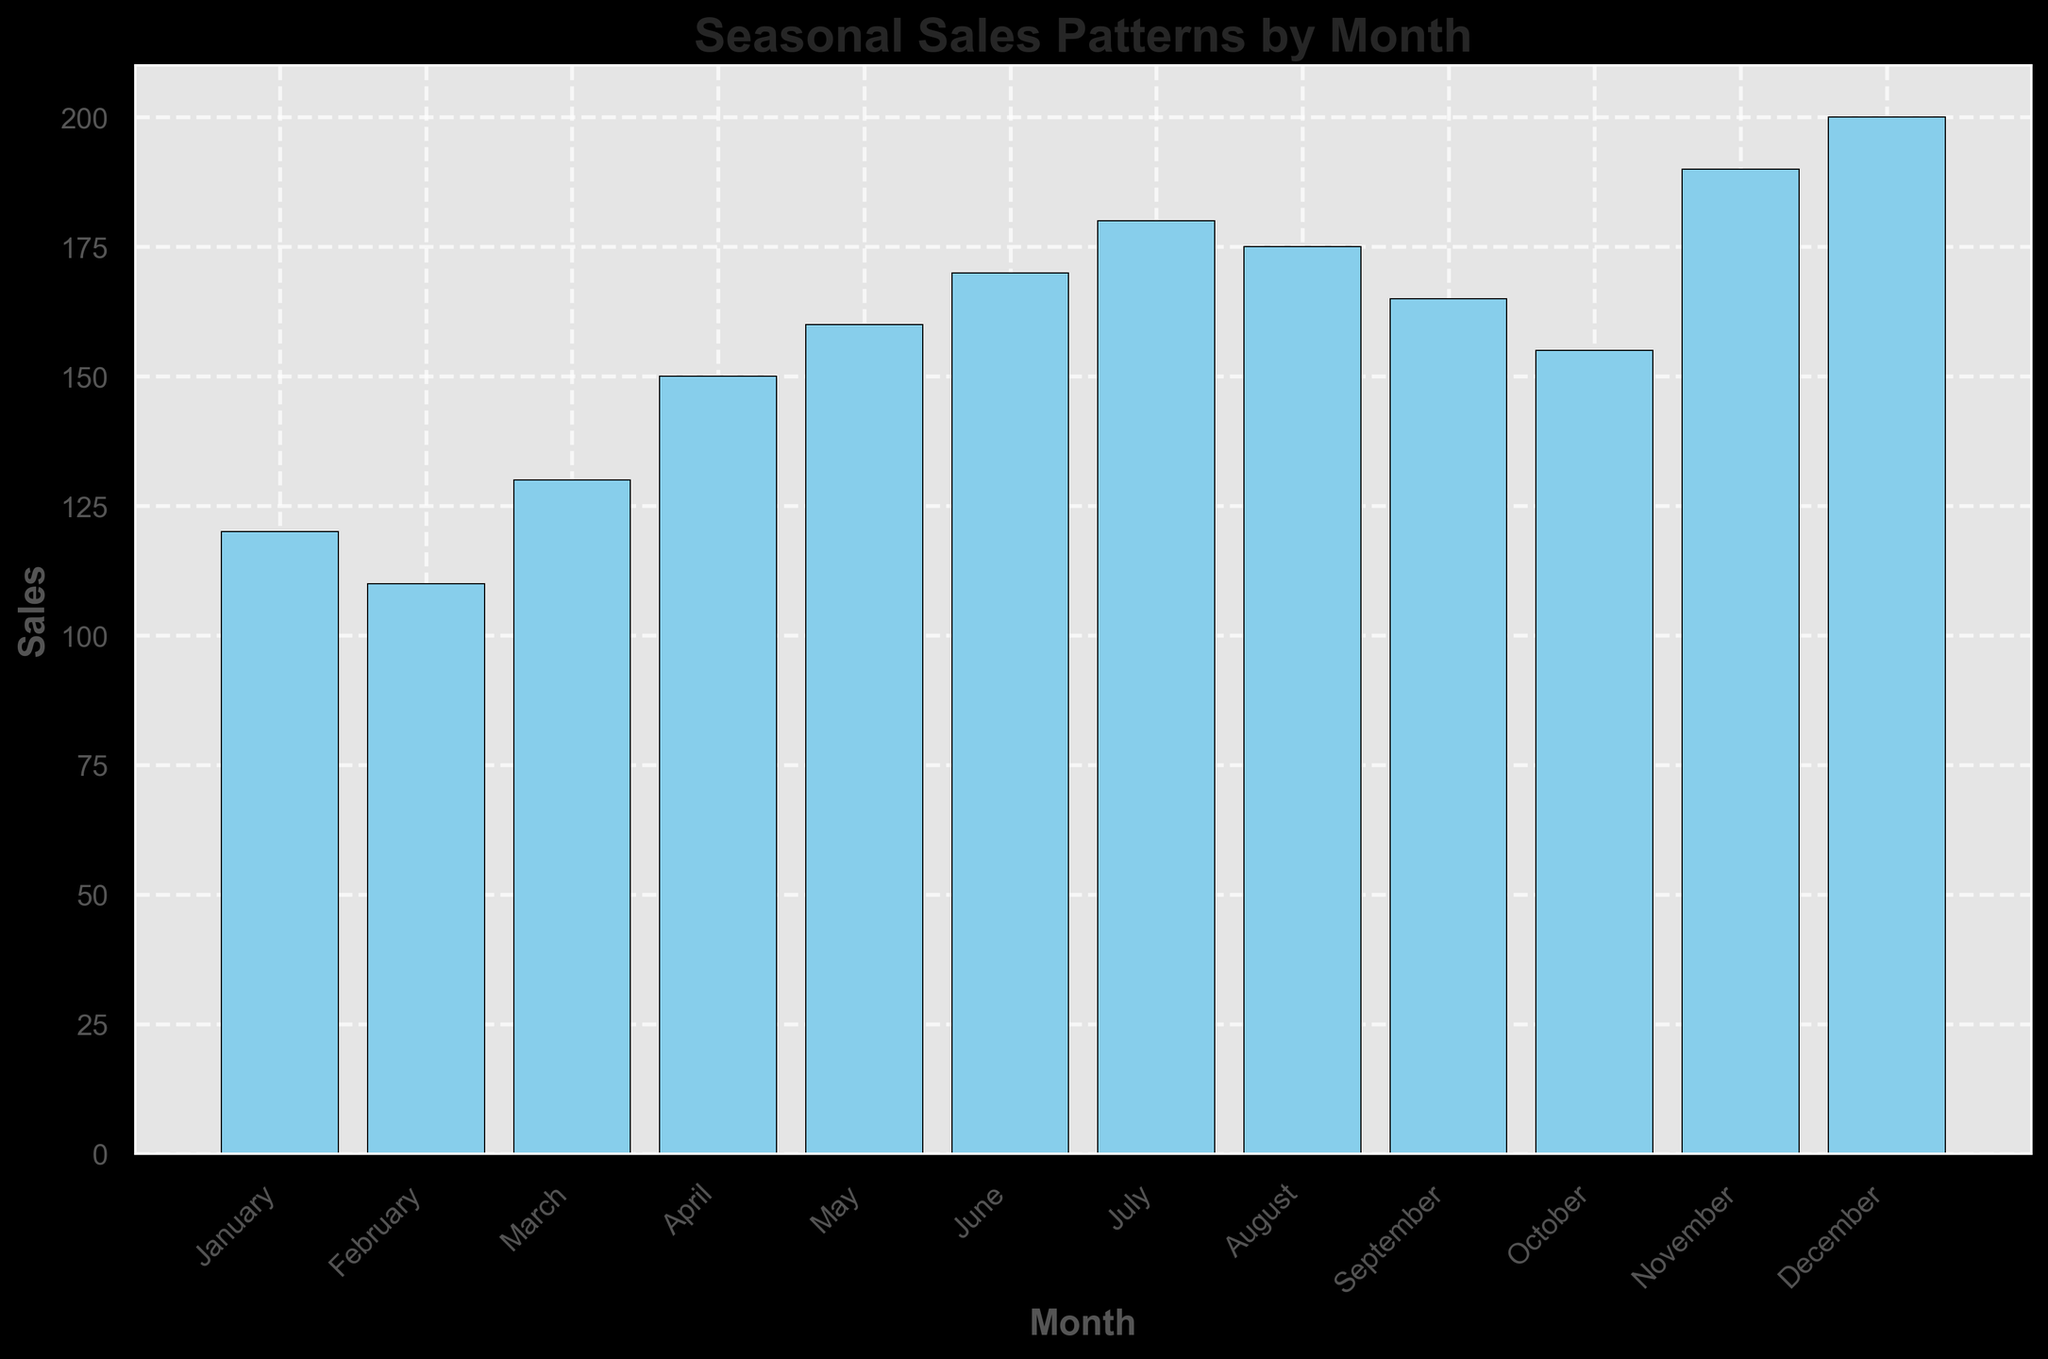Which month has the highest sales? To determine the month with the highest sales, look for the tallest bar in the histogram. The bar for December looks tallest.
Answer: December Which month has the lowest sales? To find the month with the lowest sales, identify the shortest bar in the histogram. The bar for February is the shortest.
Answer: February What is the difference in sales between July and January? Observe the heights of the bars for July and January. July has a sales value of 180, and January has a sales value of 120. Subtract January's sales from July's sales: 180 - 120 = 60.
Answer: 60 What is the average sales value for the first half of the year (Jan to June)? Sum the sales values for January to June: 120 + 110 + 130 + 150 + 160 + 170 = 840. Divide this sum by the number of months (6): 840 / 6 = 140.
Answer: 140 Which months have sales greater than 175? Identify the bars with a height greater than 175. The months with sales greater than 175 are November (190) and December (200).
Answer: November, December What is the total sales for the summer months (June, July, August)? Sum the sales values for June, July, and August: 170 + 180 + 175 = 525.
Answer: 525 Are there any months with equal sales? Observe the histogram for bars of the same height. No two bars have the same height, meaning there are no months with equal sales.
Answer: No How much higher are December's sales compared to July's sales? Subtract the sales value for July from the sales value for December: 200 - 180 = 20.
Answer: 20 Which season (group of three months) has the highest total sales, and what is their combined sales figure? Sum the sales for each season:
- Winter (Dec, Jan, Feb): 200 + 120 + 110 = 430
- Spring (Mar, Apr, May): 130 + 150 + 160 = 440
- Summer (Jun, Jul, Aug): 170 + 180 + 175 = 525
- Fall (Sep, Oct, Nov): 165 + 155 + 190 = 510
The summer season has the highest total sales of 525.
Answer: Summer, 525 What is the trend of sales from January to December? By observing the general direction from one month to the next, note that sales generally increase from January (120) to December (200) with some fluctuations.
Answer: Increasing 